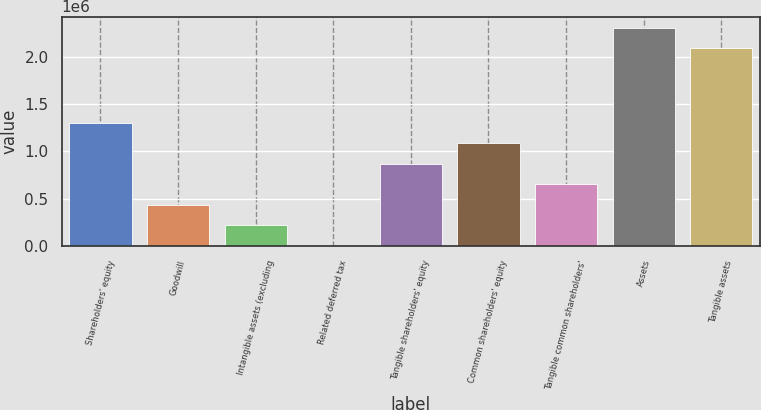Convert chart. <chart><loc_0><loc_0><loc_500><loc_500><bar_chart><fcel>Shareholders' equity<fcel>Goodwill<fcel>Intangible assets (excluding<fcel>Related deferred tax<fcel>Tangible shareholders' equity<fcel>Common shareholders' equity<fcel>Tangible common shareholders'<fcel>Assets<fcel>Tangible assets<nl><fcel>1.30072e+06<fcel>435277<fcel>218917<fcel>2556<fcel>867998<fcel>1.08436e+06<fcel>651638<fcel>2.30801e+06<fcel>2.09165e+06<nl></chart> 